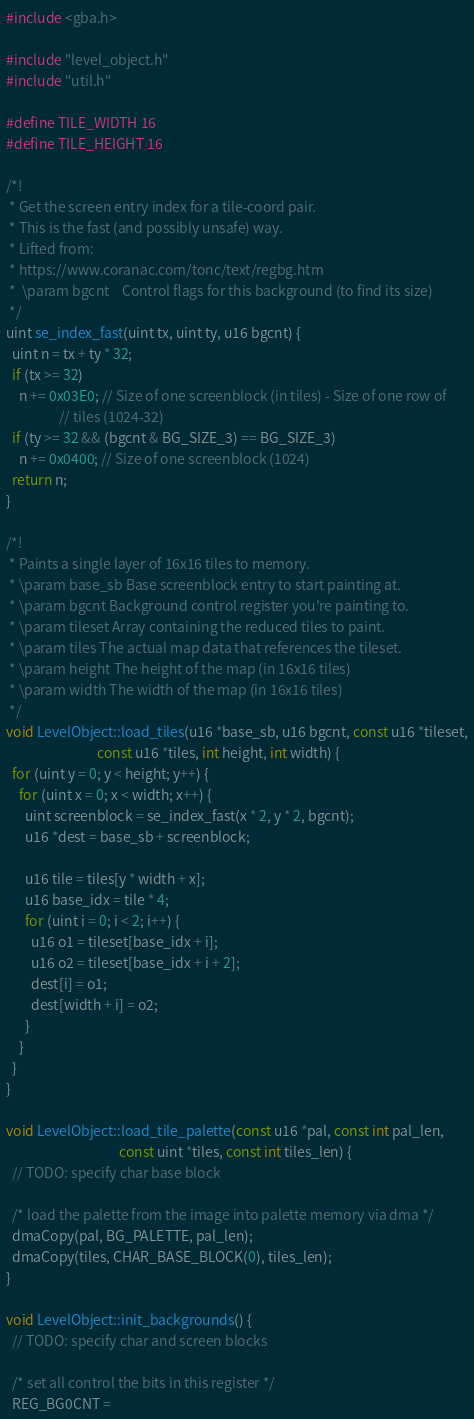<code> <loc_0><loc_0><loc_500><loc_500><_C++_>#include <gba.h>

#include "level_object.h"
#include "util.h"

#define TILE_WIDTH 16
#define TILE_HEIGHT 16

/*!
 * Get the screen entry index for a tile-coord pair.
 * This is the fast (and possibly unsafe) way.
 * Lifted from:
 * https://www.coranac.com/tonc/text/regbg.htm
 *  \param bgcnt    Control flags for this background (to find its size)
 */
uint se_index_fast(uint tx, uint ty, u16 bgcnt) {
  uint n = tx + ty * 32;
  if (tx >= 32)
    n += 0x03E0; // Size of one screenblock (in tiles) - Size of one row of
                 // tiles (1024-32)
  if (ty >= 32 && (bgcnt & BG_SIZE_3) == BG_SIZE_3)
    n += 0x0400; // Size of one screenblock (1024)
  return n;
}

/*!
 * Paints a single layer of 16x16 tiles to memory.
 * \param base_sb Base screenblock entry to start painting at.
 * \param bgcnt Background control register you're painting to.
 * \param tileset Array containing the reduced tiles to paint.
 * \param tiles The actual map data that references the tileset.
 * \param height The height of the map (in 16x16 tiles)
 * \param width The width of the map (in 16x16 tiles)
 */
void LevelObject::load_tiles(u16 *base_sb, u16 bgcnt, const u16 *tileset,
                             const u16 *tiles, int height, int width) {
  for (uint y = 0; y < height; y++) {
    for (uint x = 0; x < width; x++) {
      uint screenblock = se_index_fast(x * 2, y * 2, bgcnt);
      u16 *dest = base_sb + screenblock;

      u16 tile = tiles[y * width + x];
      u16 base_idx = tile * 4;
      for (uint i = 0; i < 2; i++) {
        u16 o1 = tileset[base_idx + i];
        u16 o2 = tileset[base_idx + i + 2];
        dest[i] = o1;
        dest[width + i] = o2;
      }
    }
  }
}

void LevelObject::load_tile_palette(const u16 *pal, const int pal_len,
                                    const uint *tiles, const int tiles_len) {
  // TODO: specify char base block

  /* load the palette from the image into palette memory via dma */
  dmaCopy(pal, BG_PALETTE, pal_len);
  dmaCopy(tiles, CHAR_BASE_BLOCK(0), tiles_len);
}

void LevelObject::init_backgrounds() {
  // TODO: specify char and screen blocks

  /* set all control the bits in this register */
  REG_BG0CNT =</code> 